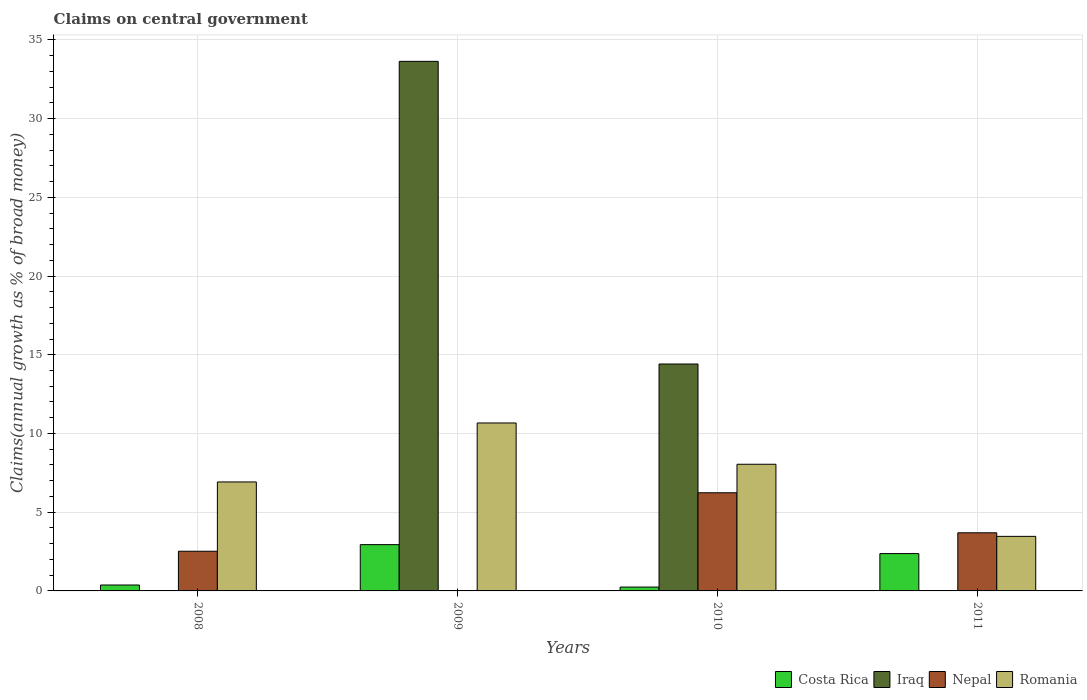How many different coloured bars are there?
Provide a succinct answer. 4. How many groups of bars are there?
Your answer should be compact. 4. Are the number of bars per tick equal to the number of legend labels?
Keep it short and to the point. No. How many bars are there on the 2nd tick from the left?
Your answer should be compact. 3. How many bars are there on the 1st tick from the right?
Offer a very short reply. 3. What is the label of the 3rd group of bars from the left?
Give a very brief answer. 2010. In how many cases, is the number of bars for a given year not equal to the number of legend labels?
Your answer should be very brief. 3. What is the percentage of broad money claimed on centeral government in Romania in 2008?
Provide a succinct answer. 6.92. Across all years, what is the maximum percentage of broad money claimed on centeral government in Romania?
Offer a very short reply. 10.67. Across all years, what is the minimum percentage of broad money claimed on centeral government in Costa Rica?
Offer a terse response. 0.24. What is the total percentage of broad money claimed on centeral government in Romania in the graph?
Keep it short and to the point. 29.1. What is the difference between the percentage of broad money claimed on centeral government in Costa Rica in 2008 and that in 2011?
Your answer should be compact. -2. What is the difference between the percentage of broad money claimed on centeral government in Costa Rica in 2008 and the percentage of broad money claimed on centeral government in Romania in 2009?
Your answer should be compact. -10.29. What is the average percentage of broad money claimed on centeral government in Nepal per year?
Your answer should be compact. 3.11. In the year 2010, what is the difference between the percentage of broad money claimed on centeral government in Iraq and percentage of broad money claimed on centeral government in Nepal?
Your answer should be very brief. 8.18. What is the ratio of the percentage of broad money claimed on centeral government in Costa Rica in 2008 to that in 2011?
Keep it short and to the point. 0.16. Is the percentage of broad money claimed on centeral government in Romania in 2009 less than that in 2010?
Offer a terse response. No. What is the difference between the highest and the second highest percentage of broad money claimed on centeral government in Romania?
Provide a short and direct response. 2.62. What is the difference between the highest and the lowest percentage of broad money claimed on centeral government in Iraq?
Make the answer very short. 33.64. In how many years, is the percentage of broad money claimed on centeral government in Nepal greater than the average percentage of broad money claimed on centeral government in Nepal taken over all years?
Your answer should be very brief. 2. Is it the case that in every year, the sum of the percentage of broad money claimed on centeral government in Iraq and percentage of broad money claimed on centeral government in Nepal is greater than the percentage of broad money claimed on centeral government in Costa Rica?
Your answer should be compact. Yes. How many bars are there?
Provide a short and direct response. 13. How many years are there in the graph?
Make the answer very short. 4. Are the values on the major ticks of Y-axis written in scientific E-notation?
Offer a terse response. No. What is the title of the graph?
Make the answer very short. Claims on central government. Does "San Marino" appear as one of the legend labels in the graph?
Provide a short and direct response. No. What is the label or title of the X-axis?
Your response must be concise. Years. What is the label or title of the Y-axis?
Provide a succinct answer. Claims(annual growth as % of broad money). What is the Claims(annual growth as % of broad money) in Costa Rica in 2008?
Your response must be concise. 0.38. What is the Claims(annual growth as % of broad money) in Nepal in 2008?
Keep it short and to the point. 2.52. What is the Claims(annual growth as % of broad money) in Romania in 2008?
Your answer should be very brief. 6.92. What is the Claims(annual growth as % of broad money) in Costa Rica in 2009?
Make the answer very short. 2.94. What is the Claims(annual growth as % of broad money) of Iraq in 2009?
Provide a short and direct response. 33.64. What is the Claims(annual growth as % of broad money) of Romania in 2009?
Provide a short and direct response. 10.67. What is the Claims(annual growth as % of broad money) of Costa Rica in 2010?
Your answer should be compact. 0.24. What is the Claims(annual growth as % of broad money) of Iraq in 2010?
Offer a very short reply. 14.41. What is the Claims(annual growth as % of broad money) in Nepal in 2010?
Make the answer very short. 6.23. What is the Claims(annual growth as % of broad money) in Romania in 2010?
Your answer should be compact. 8.05. What is the Claims(annual growth as % of broad money) of Costa Rica in 2011?
Your response must be concise. 2.37. What is the Claims(annual growth as % of broad money) in Nepal in 2011?
Provide a succinct answer. 3.69. What is the Claims(annual growth as % of broad money) in Romania in 2011?
Provide a succinct answer. 3.47. Across all years, what is the maximum Claims(annual growth as % of broad money) of Costa Rica?
Give a very brief answer. 2.94. Across all years, what is the maximum Claims(annual growth as % of broad money) in Iraq?
Keep it short and to the point. 33.64. Across all years, what is the maximum Claims(annual growth as % of broad money) in Nepal?
Keep it short and to the point. 6.23. Across all years, what is the maximum Claims(annual growth as % of broad money) in Romania?
Your answer should be very brief. 10.67. Across all years, what is the minimum Claims(annual growth as % of broad money) in Costa Rica?
Your response must be concise. 0.24. Across all years, what is the minimum Claims(annual growth as % of broad money) of Romania?
Your response must be concise. 3.47. What is the total Claims(annual growth as % of broad money) in Costa Rica in the graph?
Your answer should be compact. 5.93. What is the total Claims(annual growth as % of broad money) of Iraq in the graph?
Your answer should be very brief. 48.05. What is the total Claims(annual growth as % of broad money) of Nepal in the graph?
Provide a short and direct response. 12.45. What is the total Claims(annual growth as % of broad money) of Romania in the graph?
Your answer should be very brief. 29.1. What is the difference between the Claims(annual growth as % of broad money) in Costa Rica in 2008 and that in 2009?
Keep it short and to the point. -2.56. What is the difference between the Claims(annual growth as % of broad money) in Romania in 2008 and that in 2009?
Offer a terse response. -3.75. What is the difference between the Claims(annual growth as % of broad money) in Costa Rica in 2008 and that in 2010?
Your answer should be compact. 0.13. What is the difference between the Claims(annual growth as % of broad money) of Nepal in 2008 and that in 2010?
Make the answer very short. -3.71. What is the difference between the Claims(annual growth as % of broad money) in Romania in 2008 and that in 2010?
Keep it short and to the point. -1.12. What is the difference between the Claims(annual growth as % of broad money) of Costa Rica in 2008 and that in 2011?
Give a very brief answer. -2. What is the difference between the Claims(annual growth as % of broad money) of Nepal in 2008 and that in 2011?
Give a very brief answer. -1.17. What is the difference between the Claims(annual growth as % of broad money) in Romania in 2008 and that in 2011?
Offer a very short reply. 3.46. What is the difference between the Claims(annual growth as % of broad money) of Costa Rica in 2009 and that in 2010?
Make the answer very short. 2.7. What is the difference between the Claims(annual growth as % of broad money) in Iraq in 2009 and that in 2010?
Give a very brief answer. 19.22. What is the difference between the Claims(annual growth as % of broad money) in Romania in 2009 and that in 2010?
Offer a very short reply. 2.62. What is the difference between the Claims(annual growth as % of broad money) in Costa Rica in 2009 and that in 2011?
Your answer should be very brief. 0.57. What is the difference between the Claims(annual growth as % of broad money) in Romania in 2009 and that in 2011?
Your response must be concise. 7.2. What is the difference between the Claims(annual growth as % of broad money) in Costa Rica in 2010 and that in 2011?
Provide a succinct answer. -2.13. What is the difference between the Claims(annual growth as % of broad money) in Nepal in 2010 and that in 2011?
Keep it short and to the point. 2.54. What is the difference between the Claims(annual growth as % of broad money) of Romania in 2010 and that in 2011?
Give a very brief answer. 4.58. What is the difference between the Claims(annual growth as % of broad money) of Costa Rica in 2008 and the Claims(annual growth as % of broad money) of Iraq in 2009?
Keep it short and to the point. -33.26. What is the difference between the Claims(annual growth as % of broad money) in Costa Rica in 2008 and the Claims(annual growth as % of broad money) in Romania in 2009?
Give a very brief answer. -10.29. What is the difference between the Claims(annual growth as % of broad money) in Nepal in 2008 and the Claims(annual growth as % of broad money) in Romania in 2009?
Offer a terse response. -8.15. What is the difference between the Claims(annual growth as % of broad money) of Costa Rica in 2008 and the Claims(annual growth as % of broad money) of Iraq in 2010?
Your answer should be very brief. -14.04. What is the difference between the Claims(annual growth as % of broad money) of Costa Rica in 2008 and the Claims(annual growth as % of broad money) of Nepal in 2010?
Ensure brevity in your answer.  -5.86. What is the difference between the Claims(annual growth as % of broad money) in Costa Rica in 2008 and the Claims(annual growth as % of broad money) in Romania in 2010?
Offer a terse response. -7.67. What is the difference between the Claims(annual growth as % of broad money) of Nepal in 2008 and the Claims(annual growth as % of broad money) of Romania in 2010?
Your answer should be compact. -5.53. What is the difference between the Claims(annual growth as % of broad money) in Costa Rica in 2008 and the Claims(annual growth as % of broad money) in Nepal in 2011?
Give a very brief answer. -3.32. What is the difference between the Claims(annual growth as % of broad money) in Costa Rica in 2008 and the Claims(annual growth as % of broad money) in Romania in 2011?
Make the answer very short. -3.09. What is the difference between the Claims(annual growth as % of broad money) in Nepal in 2008 and the Claims(annual growth as % of broad money) in Romania in 2011?
Offer a very short reply. -0.95. What is the difference between the Claims(annual growth as % of broad money) of Costa Rica in 2009 and the Claims(annual growth as % of broad money) of Iraq in 2010?
Your answer should be compact. -11.47. What is the difference between the Claims(annual growth as % of broad money) in Costa Rica in 2009 and the Claims(annual growth as % of broad money) in Nepal in 2010?
Your answer should be very brief. -3.29. What is the difference between the Claims(annual growth as % of broad money) in Costa Rica in 2009 and the Claims(annual growth as % of broad money) in Romania in 2010?
Provide a succinct answer. -5.11. What is the difference between the Claims(annual growth as % of broad money) of Iraq in 2009 and the Claims(annual growth as % of broad money) of Nepal in 2010?
Make the answer very short. 27.4. What is the difference between the Claims(annual growth as % of broad money) in Iraq in 2009 and the Claims(annual growth as % of broad money) in Romania in 2010?
Provide a short and direct response. 25.59. What is the difference between the Claims(annual growth as % of broad money) of Costa Rica in 2009 and the Claims(annual growth as % of broad money) of Nepal in 2011?
Your response must be concise. -0.75. What is the difference between the Claims(annual growth as % of broad money) in Costa Rica in 2009 and the Claims(annual growth as % of broad money) in Romania in 2011?
Ensure brevity in your answer.  -0.53. What is the difference between the Claims(annual growth as % of broad money) in Iraq in 2009 and the Claims(annual growth as % of broad money) in Nepal in 2011?
Give a very brief answer. 29.94. What is the difference between the Claims(annual growth as % of broad money) of Iraq in 2009 and the Claims(annual growth as % of broad money) of Romania in 2011?
Provide a succinct answer. 30.17. What is the difference between the Claims(annual growth as % of broad money) of Costa Rica in 2010 and the Claims(annual growth as % of broad money) of Nepal in 2011?
Give a very brief answer. -3.45. What is the difference between the Claims(annual growth as % of broad money) in Costa Rica in 2010 and the Claims(annual growth as % of broad money) in Romania in 2011?
Your answer should be very brief. -3.22. What is the difference between the Claims(annual growth as % of broad money) of Iraq in 2010 and the Claims(annual growth as % of broad money) of Nepal in 2011?
Make the answer very short. 10.72. What is the difference between the Claims(annual growth as % of broad money) of Iraq in 2010 and the Claims(annual growth as % of broad money) of Romania in 2011?
Ensure brevity in your answer.  10.95. What is the difference between the Claims(annual growth as % of broad money) in Nepal in 2010 and the Claims(annual growth as % of broad money) in Romania in 2011?
Provide a succinct answer. 2.77. What is the average Claims(annual growth as % of broad money) of Costa Rica per year?
Provide a succinct answer. 1.48. What is the average Claims(annual growth as % of broad money) of Iraq per year?
Your answer should be compact. 12.01. What is the average Claims(annual growth as % of broad money) of Nepal per year?
Keep it short and to the point. 3.11. What is the average Claims(annual growth as % of broad money) of Romania per year?
Your answer should be compact. 7.28. In the year 2008, what is the difference between the Claims(annual growth as % of broad money) in Costa Rica and Claims(annual growth as % of broad money) in Nepal?
Provide a succinct answer. -2.14. In the year 2008, what is the difference between the Claims(annual growth as % of broad money) of Costa Rica and Claims(annual growth as % of broad money) of Romania?
Make the answer very short. -6.55. In the year 2008, what is the difference between the Claims(annual growth as % of broad money) of Nepal and Claims(annual growth as % of broad money) of Romania?
Ensure brevity in your answer.  -4.4. In the year 2009, what is the difference between the Claims(annual growth as % of broad money) of Costa Rica and Claims(annual growth as % of broad money) of Iraq?
Your answer should be very brief. -30.7. In the year 2009, what is the difference between the Claims(annual growth as % of broad money) of Costa Rica and Claims(annual growth as % of broad money) of Romania?
Keep it short and to the point. -7.73. In the year 2009, what is the difference between the Claims(annual growth as % of broad money) of Iraq and Claims(annual growth as % of broad money) of Romania?
Provide a succinct answer. 22.97. In the year 2010, what is the difference between the Claims(annual growth as % of broad money) of Costa Rica and Claims(annual growth as % of broad money) of Iraq?
Provide a short and direct response. -14.17. In the year 2010, what is the difference between the Claims(annual growth as % of broad money) of Costa Rica and Claims(annual growth as % of broad money) of Nepal?
Offer a very short reply. -5.99. In the year 2010, what is the difference between the Claims(annual growth as % of broad money) of Costa Rica and Claims(annual growth as % of broad money) of Romania?
Your answer should be very brief. -7.8. In the year 2010, what is the difference between the Claims(annual growth as % of broad money) in Iraq and Claims(annual growth as % of broad money) in Nepal?
Offer a terse response. 8.18. In the year 2010, what is the difference between the Claims(annual growth as % of broad money) of Iraq and Claims(annual growth as % of broad money) of Romania?
Give a very brief answer. 6.37. In the year 2010, what is the difference between the Claims(annual growth as % of broad money) of Nepal and Claims(annual growth as % of broad money) of Romania?
Keep it short and to the point. -1.81. In the year 2011, what is the difference between the Claims(annual growth as % of broad money) of Costa Rica and Claims(annual growth as % of broad money) of Nepal?
Your answer should be very brief. -1.32. In the year 2011, what is the difference between the Claims(annual growth as % of broad money) in Costa Rica and Claims(annual growth as % of broad money) in Romania?
Offer a terse response. -1.09. In the year 2011, what is the difference between the Claims(annual growth as % of broad money) in Nepal and Claims(annual growth as % of broad money) in Romania?
Make the answer very short. 0.23. What is the ratio of the Claims(annual growth as % of broad money) in Costa Rica in 2008 to that in 2009?
Provide a short and direct response. 0.13. What is the ratio of the Claims(annual growth as % of broad money) in Romania in 2008 to that in 2009?
Keep it short and to the point. 0.65. What is the ratio of the Claims(annual growth as % of broad money) of Costa Rica in 2008 to that in 2010?
Your answer should be compact. 1.54. What is the ratio of the Claims(annual growth as % of broad money) of Nepal in 2008 to that in 2010?
Provide a succinct answer. 0.4. What is the ratio of the Claims(annual growth as % of broad money) of Romania in 2008 to that in 2010?
Give a very brief answer. 0.86. What is the ratio of the Claims(annual growth as % of broad money) of Costa Rica in 2008 to that in 2011?
Your answer should be compact. 0.16. What is the ratio of the Claims(annual growth as % of broad money) of Nepal in 2008 to that in 2011?
Offer a terse response. 0.68. What is the ratio of the Claims(annual growth as % of broad money) of Romania in 2008 to that in 2011?
Your answer should be compact. 2. What is the ratio of the Claims(annual growth as % of broad money) of Costa Rica in 2009 to that in 2010?
Keep it short and to the point. 12.02. What is the ratio of the Claims(annual growth as % of broad money) of Iraq in 2009 to that in 2010?
Your answer should be very brief. 2.33. What is the ratio of the Claims(annual growth as % of broad money) of Romania in 2009 to that in 2010?
Provide a succinct answer. 1.33. What is the ratio of the Claims(annual growth as % of broad money) in Costa Rica in 2009 to that in 2011?
Your response must be concise. 1.24. What is the ratio of the Claims(annual growth as % of broad money) of Romania in 2009 to that in 2011?
Keep it short and to the point. 3.08. What is the ratio of the Claims(annual growth as % of broad money) of Costa Rica in 2010 to that in 2011?
Make the answer very short. 0.1. What is the ratio of the Claims(annual growth as % of broad money) of Nepal in 2010 to that in 2011?
Offer a very short reply. 1.69. What is the ratio of the Claims(annual growth as % of broad money) in Romania in 2010 to that in 2011?
Your response must be concise. 2.32. What is the difference between the highest and the second highest Claims(annual growth as % of broad money) of Costa Rica?
Your answer should be compact. 0.57. What is the difference between the highest and the second highest Claims(annual growth as % of broad money) in Nepal?
Your answer should be very brief. 2.54. What is the difference between the highest and the second highest Claims(annual growth as % of broad money) of Romania?
Your answer should be compact. 2.62. What is the difference between the highest and the lowest Claims(annual growth as % of broad money) in Costa Rica?
Offer a very short reply. 2.7. What is the difference between the highest and the lowest Claims(annual growth as % of broad money) of Iraq?
Provide a short and direct response. 33.64. What is the difference between the highest and the lowest Claims(annual growth as % of broad money) in Nepal?
Make the answer very short. 6.23. What is the difference between the highest and the lowest Claims(annual growth as % of broad money) in Romania?
Offer a terse response. 7.2. 